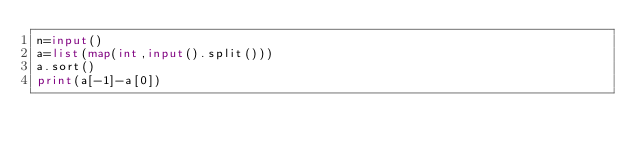<code> <loc_0><loc_0><loc_500><loc_500><_Python_>n=input()
a=list(map(int,input().split()))
a.sort()
print(a[-1]-a[0])</code> 